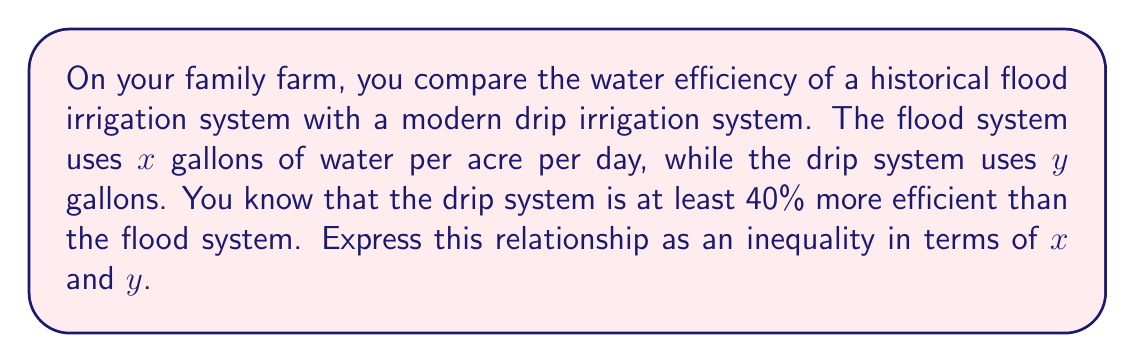Can you solve this math problem? Let's approach this step-by-step:

1) We're told that the drip system is at least 40% more efficient than the flood system. This means it uses at most 60% of the water that the flood system uses.

2) We can express this as a fraction: $\frac{y}{x} \leq 0.6$

3) To convert this to an inequality involving $x$ and $y$, we can multiply both sides by $x$:

   $y \leq 0.6x$

4) We can also express this with $y$ on one side:

   $y \leq 0.6x$
   $y - 0.6x \leq 0$

5) This inequality represents the relationship between the water usage of the two systems, where $y$ (drip system) is at most 60% of $x$ (flood system).
Answer: $y - 0.6x \leq 0$ 